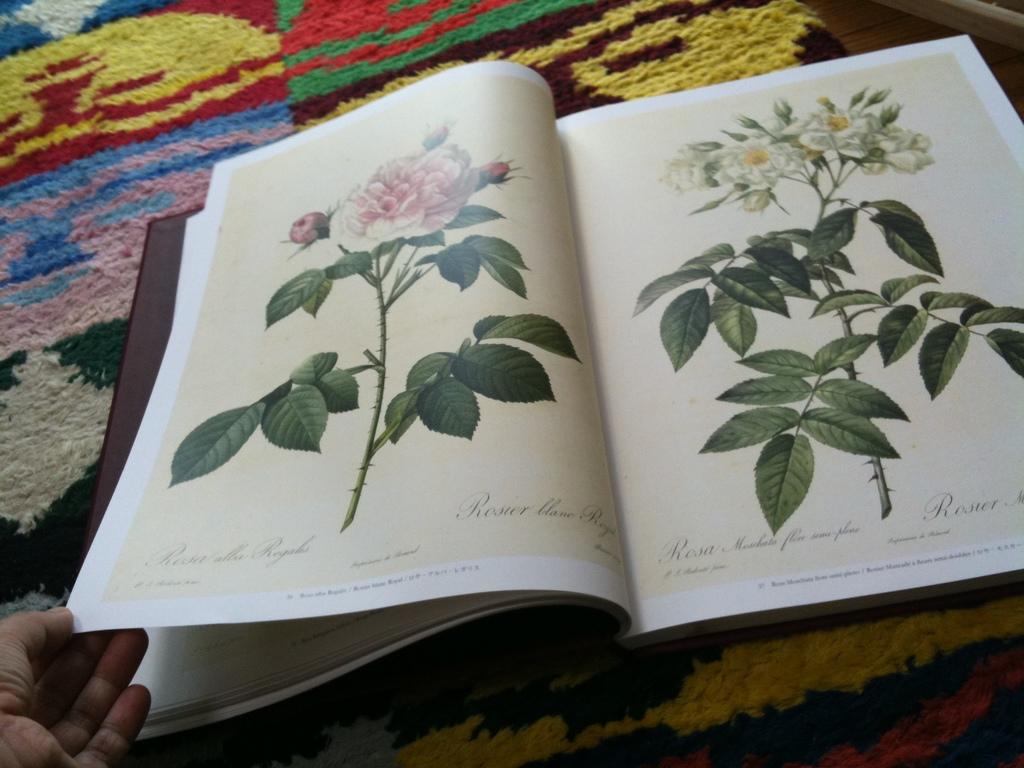Is there cursive writing on the pages?
Ensure brevity in your answer.  Yes. 